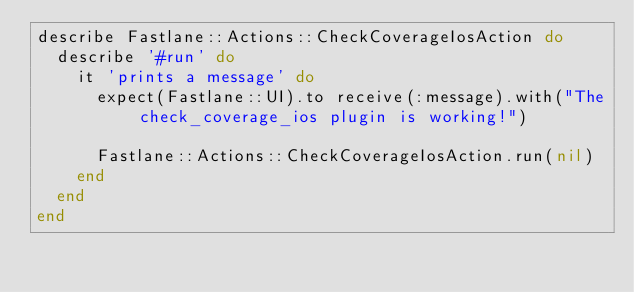<code> <loc_0><loc_0><loc_500><loc_500><_Ruby_>describe Fastlane::Actions::CheckCoverageIosAction do
  describe '#run' do
    it 'prints a message' do
      expect(Fastlane::UI).to receive(:message).with("The check_coverage_ios plugin is working!")

      Fastlane::Actions::CheckCoverageIosAction.run(nil)
    end
  end
end
</code> 